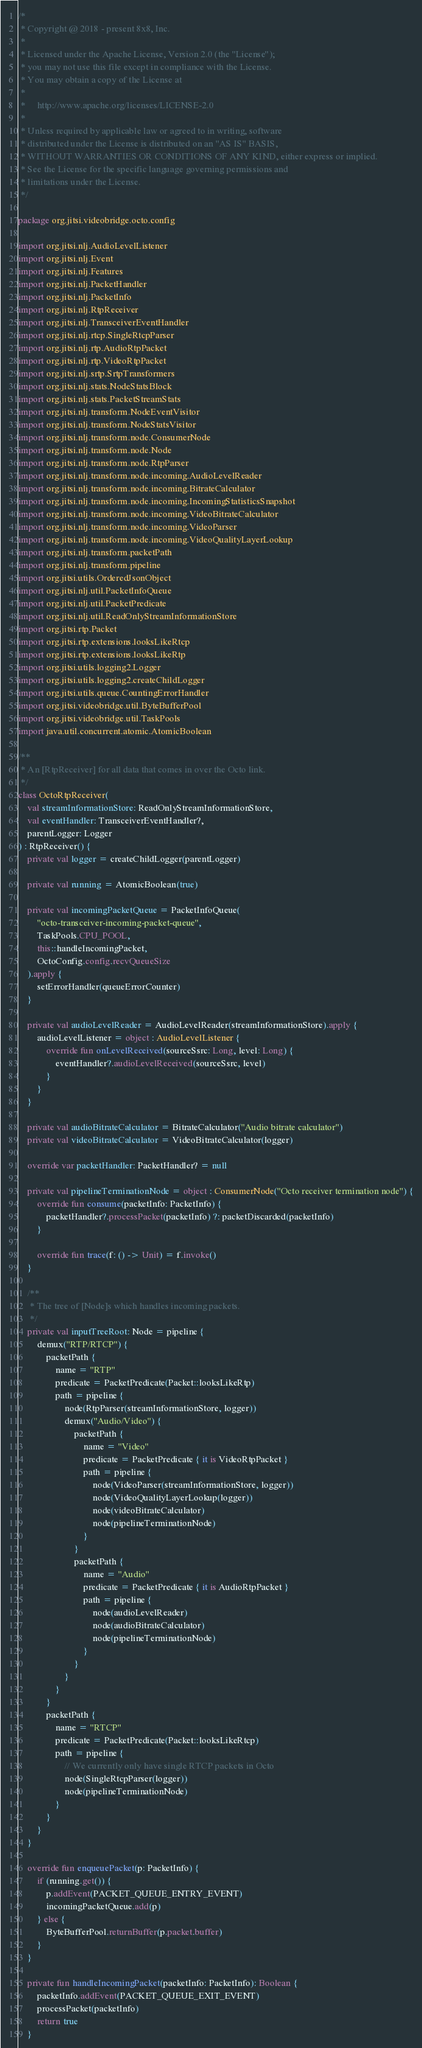Convert code to text. <code><loc_0><loc_0><loc_500><loc_500><_Kotlin_>/*
 * Copyright @ 2018 - present 8x8, Inc.
 *
 * Licensed under the Apache License, Version 2.0 (the "License");
 * you may not use this file except in compliance with the License.
 * You may obtain a copy of the License at
 *
 *     http://www.apache.org/licenses/LICENSE-2.0
 *
 * Unless required by applicable law or agreed to in writing, software
 * distributed under the License is distributed on an "AS IS" BASIS,
 * WITHOUT WARRANTIES OR CONDITIONS OF ANY KIND, either express or implied.
 * See the License for the specific language governing permissions and
 * limitations under the License.
 */

package org.jitsi.videobridge.octo.config

import org.jitsi.nlj.AudioLevelListener
import org.jitsi.nlj.Event
import org.jitsi.nlj.Features
import org.jitsi.nlj.PacketHandler
import org.jitsi.nlj.PacketInfo
import org.jitsi.nlj.RtpReceiver
import org.jitsi.nlj.TransceiverEventHandler
import org.jitsi.nlj.rtcp.SingleRtcpParser
import org.jitsi.nlj.rtp.AudioRtpPacket
import org.jitsi.nlj.rtp.VideoRtpPacket
import org.jitsi.nlj.srtp.SrtpTransformers
import org.jitsi.nlj.stats.NodeStatsBlock
import org.jitsi.nlj.stats.PacketStreamStats
import org.jitsi.nlj.transform.NodeEventVisitor
import org.jitsi.nlj.transform.NodeStatsVisitor
import org.jitsi.nlj.transform.node.ConsumerNode
import org.jitsi.nlj.transform.node.Node
import org.jitsi.nlj.transform.node.RtpParser
import org.jitsi.nlj.transform.node.incoming.AudioLevelReader
import org.jitsi.nlj.transform.node.incoming.BitrateCalculator
import org.jitsi.nlj.transform.node.incoming.IncomingStatisticsSnapshot
import org.jitsi.nlj.transform.node.incoming.VideoBitrateCalculator
import org.jitsi.nlj.transform.node.incoming.VideoParser
import org.jitsi.nlj.transform.node.incoming.VideoQualityLayerLookup
import org.jitsi.nlj.transform.packetPath
import org.jitsi.nlj.transform.pipeline
import org.jitsi.utils.OrderedJsonObject
import org.jitsi.nlj.util.PacketInfoQueue
import org.jitsi.nlj.util.PacketPredicate
import org.jitsi.nlj.util.ReadOnlyStreamInformationStore
import org.jitsi.rtp.Packet
import org.jitsi.rtp.extensions.looksLikeRtcp
import org.jitsi.rtp.extensions.looksLikeRtp
import org.jitsi.utils.logging2.Logger
import org.jitsi.utils.logging2.createChildLogger
import org.jitsi.utils.queue.CountingErrorHandler
import org.jitsi.videobridge.util.ByteBufferPool
import org.jitsi.videobridge.util.TaskPools
import java.util.concurrent.atomic.AtomicBoolean

/**
 * An [RtpReceiver] for all data that comes in over the Octo link.
 */
class OctoRtpReceiver(
    val streamInformationStore: ReadOnlyStreamInformationStore,
    val eventHandler: TransceiverEventHandler?,
    parentLogger: Logger
) : RtpReceiver() {
    private val logger = createChildLogger(parentLogger)

    private val running = AtomicBoolean(true)

    private val incomingPacketQueue = PacketInfoQueue(
        "octo-transceiver-incoming-packet-queue",
        TaskPools.CPU_POOL,
        this::handleIncomingPacket,
        OctoConfig.config.recvQueueSize
    ).apply {
        setErrorHandler(queueErrorCounter)
    }

    private val audioLevelReader = AudioLevelReader(streamInformationStore).apply {
        audioLevelListener = object : AudioLevelListener {
            override fun onLevelReceived(sourceSsrc: Long, level: Long) {
                eventHandler?.audioLevelReceived(sourceSsrc, level)
            }
        }
    }

    private val audioBitrateCalculator = BitrateCalculator("Audio bitrate calculator")
    private val videoBitrateCalculator = VideoBitrateCalculator(logger)

    override var packetHandler: PacketHandler? = null

    private val pipelineTerminationNode = object : ConsumerNode("Octo receiver termination node") {
        override fun consume(packetInfo: PacketInfo) {
            packetHandler?.processPacket(packetInfo) ?: packetDiscarded(packetInfo)
        }

        override fun trace(f: () -> Unit) = f.invoke()
    }

    /**
     * The tree of [Node]s which handles incoming packets.
     */
    private val inputTreeRoot: Node = pipeline {
        demux("RTP/RTCP") {
            packetPath {
                name = "RTP"
                predicate = PacketPredicate(Packet::looksLikeRtp)
                path = pipeline {
                    node(RtpParser(streamInformationStore, logger))
                    demux("Audio/Video") {
                        packetPath {
                            name = "Video"
                            predicate = PacketPredicate { it is VideoRtpPacket }
                            path = pipeline {
                                node(VideoParser(streamInformationStore, logger))
                                node(VideoQualityLayerLookup(logger))
                                node(videoBitrateCalculator)
                                node(pipelineTerminationNode)
                            }
                        }
                        packetPath {
                            name = "Audio"
                            predicate = PacketPredicate { it is AudioRtpPacket }
                            path = pipeline {
                                node(audioLevelReader)
                                node(audioBitrateCalculator)
                                node(pipelineTerminationNode)
                            }
                        }
                    }
                }
            }
            packetPath {
                name = "RTCP"
                predicate = PacketPredicate(Packet::looksLikeRtcp)
                path = pipeline {
                    // We currently only have single RTCP packets in Octo
                    node(SingleRtcpParser(logger))
                    node(pipelineTerminationNode)
                }
            }
        }
    }

    override fun enqueuePacket(p: PacketInfo) {
        if (running.get()) {
            p.addEvent(PACKET_QUEUE_ENTRY_EVENT)
            incomingPacketQueue.add(p)
        } else {
            ByteBufferPool.returnBuffer(p.packet.buffer)
        }
    }

    private fun handleIncomingPacket(packetInfo: PacketInfo): Boolean {
        packetInfo.addEvent(PACKET_QUEUE_EXIT_EVENT)
        processPacket(packetInfo)
        return true
    }
</code> 